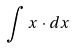<formula> <loc_0><loc_0><loc_500><loc_500>\int x \cdot d x</formula> 